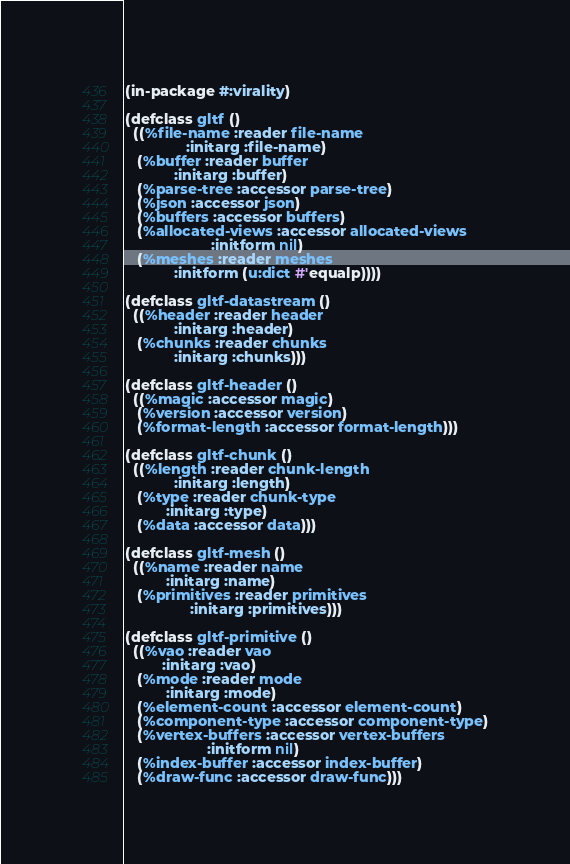Convert code to text. <code><loc_0><loc_0><loc_500><loc_500><_Lisp_>(in-package #:virality)

(defclass gltf ()
  ((%file-name :reader file-name
               :initarg :file-name)
   (%buffer :reader buffer
            :initarg :buffer)
   (%parse-tree :accessor parse-tree)
   (%json :accessor json)
   (%buffers :accessor buffers)
   (%allocated-views :accessor allocated-views
                     :initform nil)
   (%meshes :reader meshes
            :initform (u:dict #'equalp))))

(defclass gltf-datastream ()
  ((%header :reader header
            :initarg :header)
   (%chunks :reader chunks
            :initarg :chunks)))

(defclass gltf-header ()
  ((%magic :accessor magic)
   (%version :accessor version)
   (%format-length :accessor format-length)))

(defclass gltf-chunk ()
  ((%length :reader chunk-length
            :initarg :length)
   (%type :reader chunk-type
          :initarg :type)
   (%data :accessor data)))

(defclass gltf-mesh ()
  ((%name :reader name
          :initarg :name)
   (%primitives :reader primitives
                :initarg :primitives)))

(defclass gltf-primitive ()
  ((%vao :reader vao
         :initarg :vao)
   (%mode :reader mode
          :initarg :mode)
   (%element-count :accessor element-count)
   (%component-type :accessor component-type)
   (%vertex-buffers :accessor vertex-buffers
                    :initform nil)
   (%index-buffer :accessor index-buffer)
   (%draw-func :accessor draw-func)))
</code> 